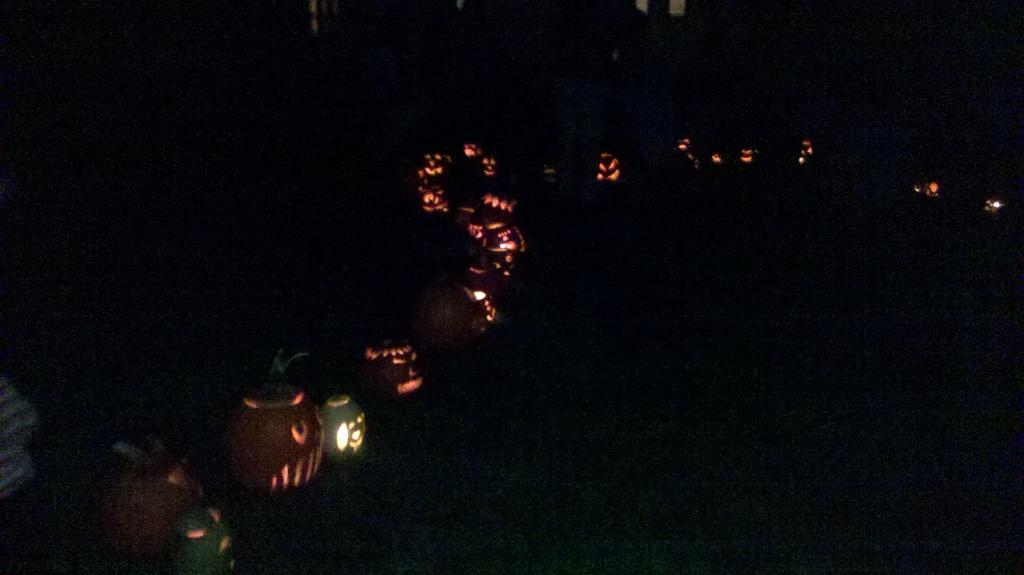What type of objects are featured in the image? There is a group of Halloween pumpkins in the image. Do the pumpkins have any special features? Yes, the pumpkins have lights. Where are the pumpkins located in the image? The pumpkins are placed on the ground. What type of wound does the sister have in the image? There is no mention of a sister or any wound in the image. 